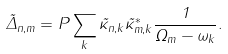Convert formula to latex. <formula><loc_0><loc_0><loc_500><loc_500>\tilde { \Delta } _ { n , m } = P \sum _ { k } \tilde { \kappa } _ { n , k } \tilde { \kappa } ^ { * } _ { m , k } \frac { 1 } { \Omega _ { m } - \omega _ { k } } .</formula> 